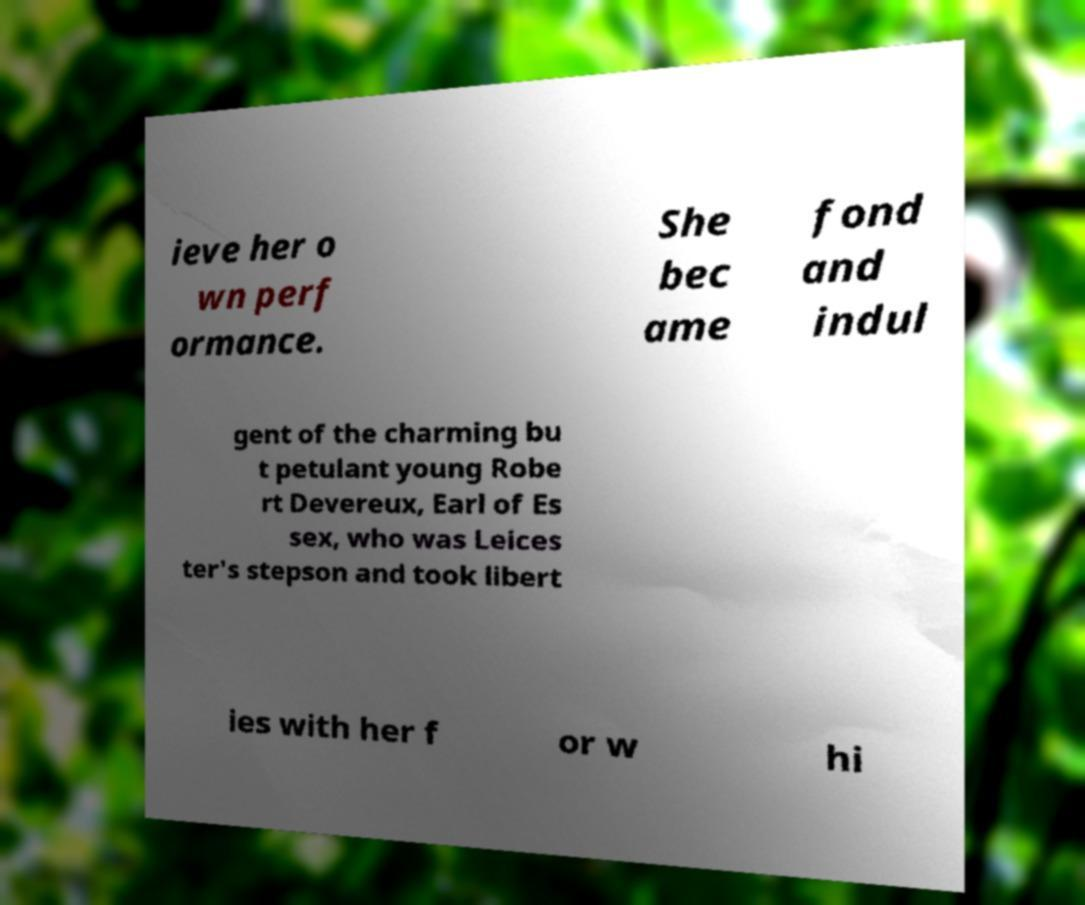There's text embedded in this image that I need extracted. Can you transcribe it verbatim? ieve her o wn perf ormance. She bec ame fond and indul gent of the charming bu t petulant young Robe rt Devereux, Earl of Es sex, who was Leices ter's stepson and took libert ies with her f or w hi 